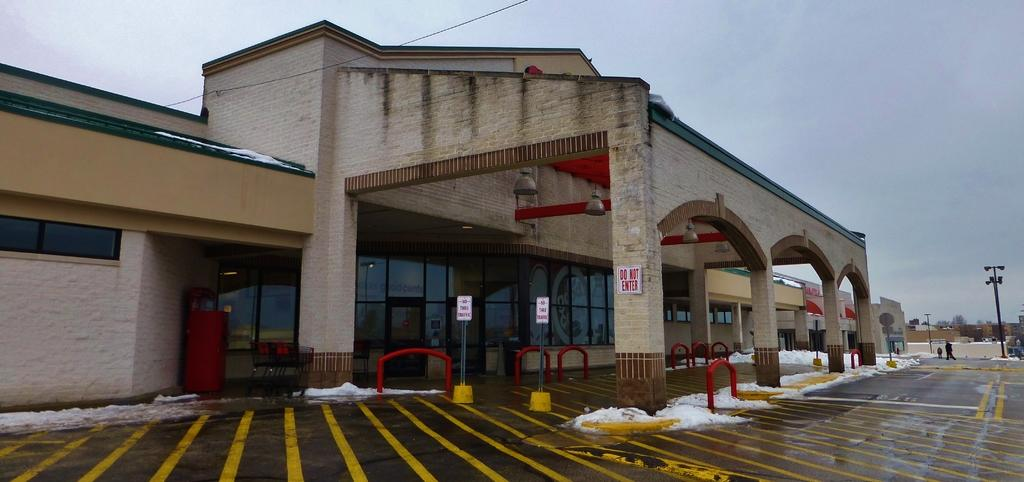<image>
Describe the image concisely. No thru traffic is allowed and a vehicle may not enter in front of a building. 